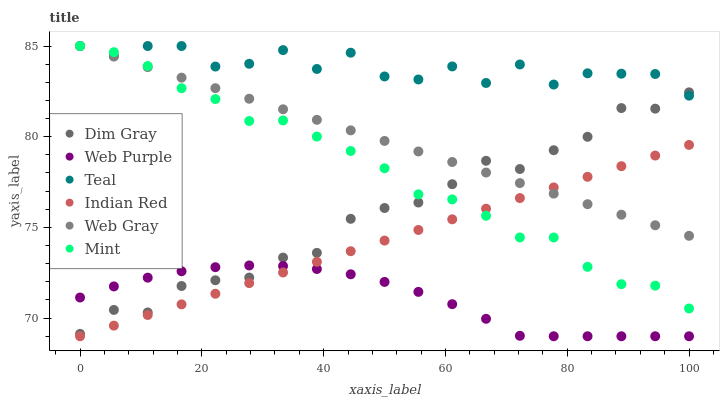Does Web Purple have the minimum area under the curve?
Answer yes or no. Yes. Does Teal have the maximum area under the curve?
Answer yes or no. Yes. Does Teal have the minimum area under the curve?
Answer yes or no. No. Does Web Purple have the maximum area under the curve?
Answer yes or no. No. Is Web Gray the smoothest?
Answer yes or no. Yes. Is Teal the roughest?
Answer yes or no. Yes. Is Web Purple the smoothest?
Answer yes or no. No. Is Web Purple the roughest?
Answer yes or no. No. Does Web Purple have the lowest value?
Answer yes or no. Yes. Does Teal have the lowest value?
Answer yes or no. No. Does Mint have the highest value?
Answer yes or no. Yes. Does Web Purple have the highest value?
Answer yes or no. No. Is Web Purple less than Web Gray?
Answer yes or no. Yes. Is Teal greater than Web Purple?
Answer yes or no. Yes. Does Mint intersect Indian Red?
Answer yes or no. Yes. Is Mint less than Indian Red?
Answer yes or no. No. Is Mint greater than Indian Red?
Answer yes or no. No. Does Web Purple intersect Web Gray?
Answer yes or no. No. 